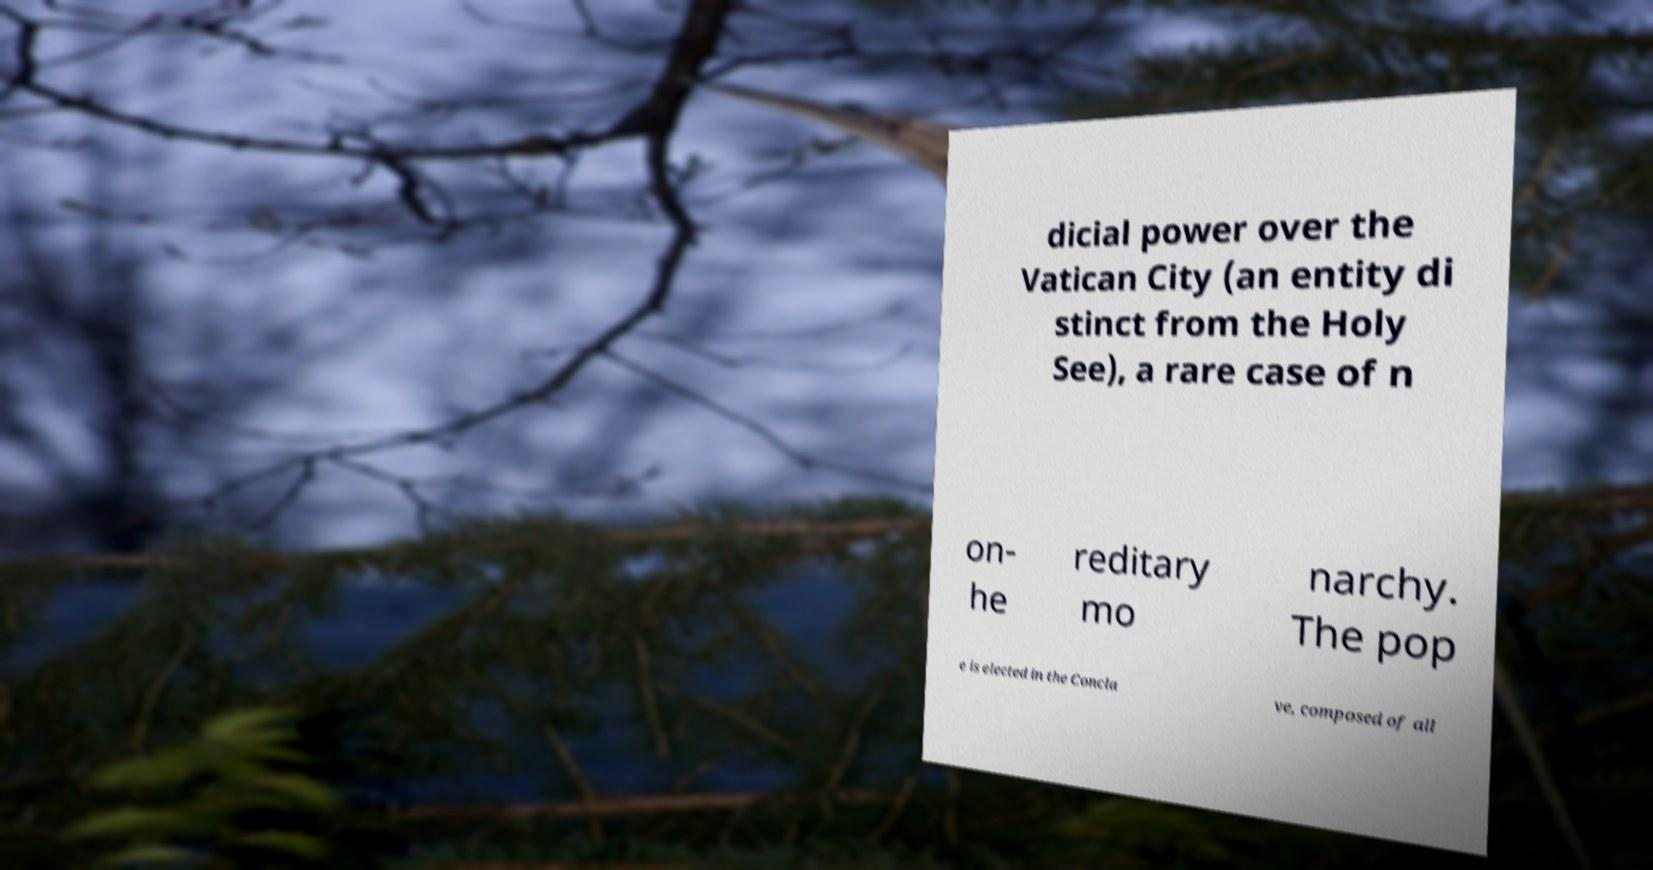Could you extract and type out the text from this image? dicial power over the Vatican City (an entity di stinct from the Holy See), a rare case of n on- he reditary mo narchy. The pop e is elected in the Concla ve, composed of all 